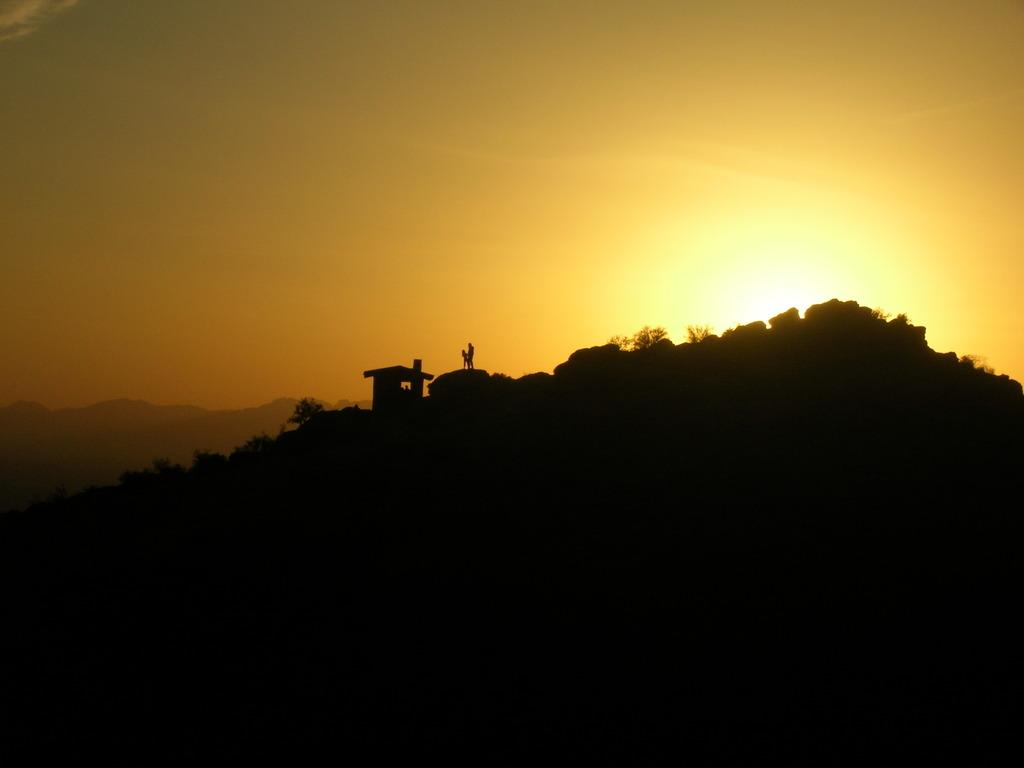How many people are in the image? There are persons in the image, but the exact number is not specified. What type of structure is present in the image? There is a house in the image. Where is the house located? The house is on a hill. What can be seen in the sky in the image? The sky is visible in the image. What is visible in the background of the image? There is another hill in the background of the image. What is the purpose of the alley in the image? There is no alley present in the image. How does the teaching take place in the image? There is no teaching or educational activity depicted in the image. 